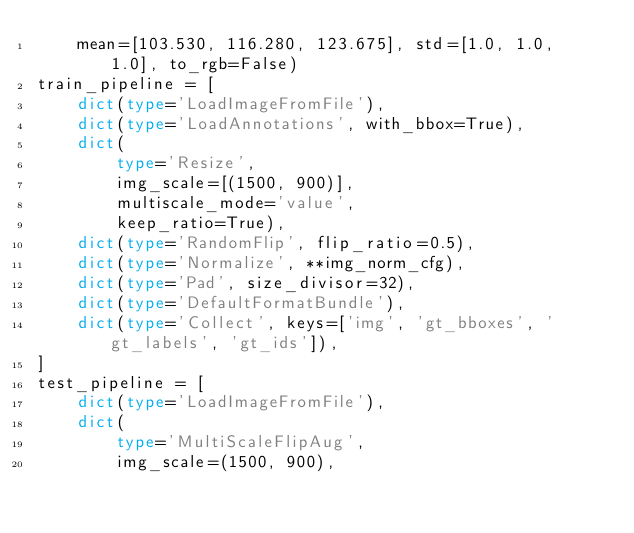<code> <loc_0><loc_0><loc_500><loc_500><_Python_>    mean=[103.530, 116.280, 123.675], std=[1.0, 1.0, 1.0], to_rgb=False)
train_pipeline = [
    dict(type='LoadImageFromFile'),
    dict(type='LoadAnnotations', with_bbox=True),
    dict(
        type='Resize',
        img_scale=[(1500, 900)],
        multiscale_mode='value',
        keep_ratio=True),
    dict(type='RandomFlip', flip_ratio=0.5),
    dict(type='Normalize', **img_norm_cfg),
    dict(type='Pad', size_divisor=32),
    dict(type='DefaultFormatBundle'),
    dict(type='Collect', keys=['img', 'gt_bboxes', 'gt_labels', 'gt_ids']),
]
test_pipeline = [
    dict(type='LoadImageFromFile'),
    dict(
        type='MultiScaleFlipAug',
        img_scale=(1500, 900),</code> 